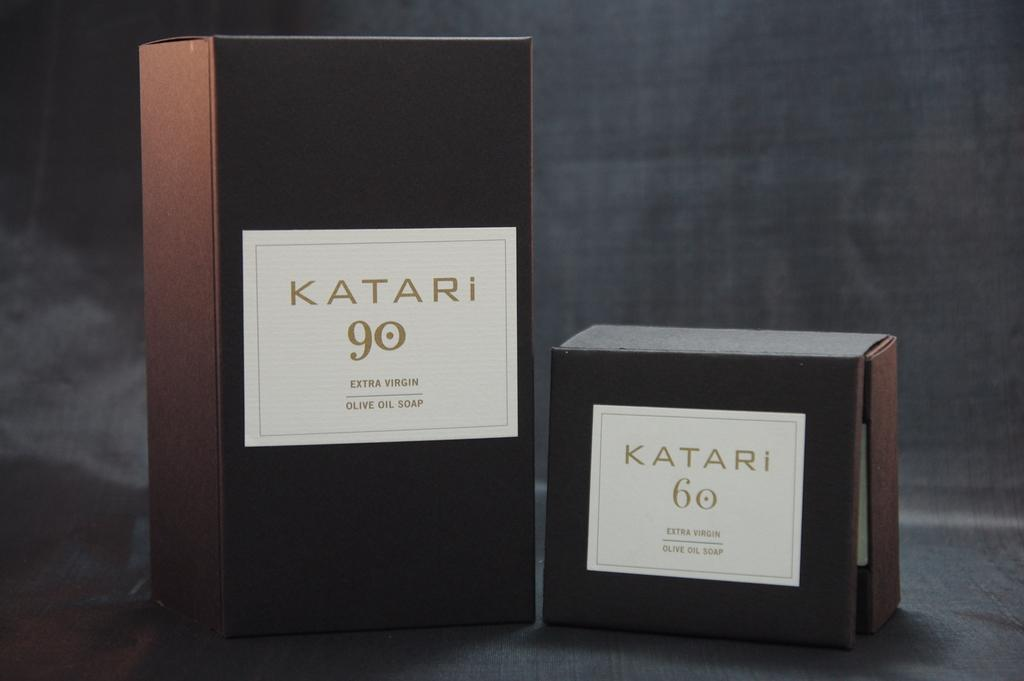<image>
Summarize the visual content of the image. boxes labeled katari 90 extra virgin olive oil soap and katari 60 